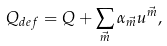<formula> <loc_0><loc_0><loc_500><loc_500>Q _ { d e f } = Q + \sum _ { \vec { m } } \alpha _ { \vec { m } } u ^ { \vec { m } } ,</formula> 